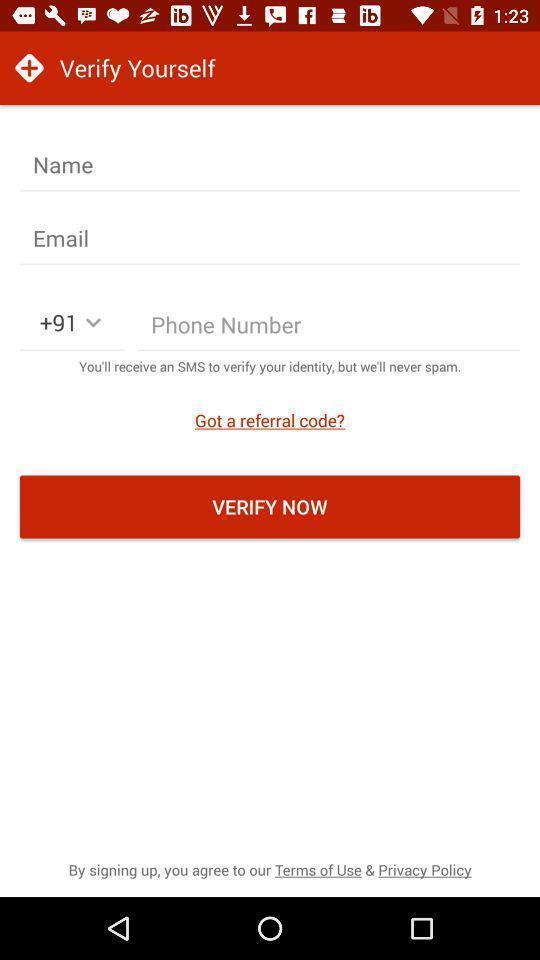Summarize the information in this screenshot. Page displaying verify option for a doctors app. 